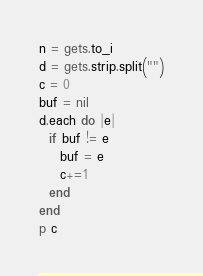<code> <loc_0><loc_0><loc_500><loc_500><_Ruby_>n = gets.to_i
d = gets.strip.split("")
c = 0
buf = nil
d.each do |e|
  if buf != e
    buf = e
    c+=1
  end
end
p c</code> 